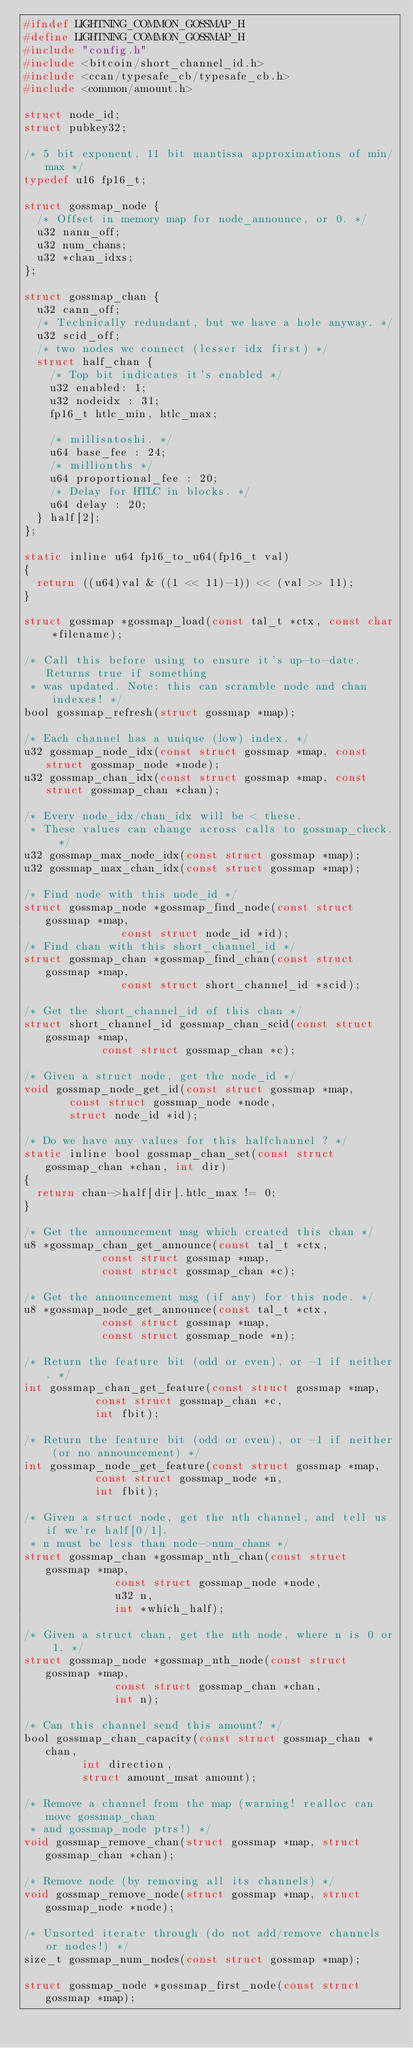<code> <loc_0><loc_0><loc_500><loc_500><_C_>#ifndef LIGHTNING_COMMON_GOSSMAP_H
#define LIGHTNING_COMMON_GOSSMAP_H
#include "config.h"
#include <bitcoin/short_channel_id.h>
#include <ccan/typesafe_cb/typesafe_cb.h>
#include <common/amount.h>

struct node_id;
struct pubkey32;

/* 5 bit exponent, 11 bit mantissa approximations of min/max */
typedef u16 fp16_t;

struct gossmap_node {
	/* Offset in memory map for node_announce, or 0. */
	u32 nann_off;
	u32 num_chans;
	u32 *chan_idxs;
};

struct gossmap_chan {
	u32 cann_off;
	/* Technically redundant, but we have a hole anyway. */
	u32 scid_off;
	/* two nodes we connect (lesser idx first) */
	struct half_chan {
		/* Top bit indicates it's enabled */
		u32 enabled: 1;
		u32 nodeidx : 31;
		fp16_t htlc_min, htlc_max;

		/* millisatoshi. */
		u64 base_fee : 24;
		/* millionths */
		u64 proportional_fee : 20;
		/* Delay for HTLC in blocks. */
		u64 delay : 20;
	} half[2];
};

static inline u64 fp16_to_u64(fp16_t val)
{
	return ((u64)val & ((1 << 11)-1)) << (val >> 11);
}

struct gossmap *gossmap_load(const tal_t *ctx, const char *filename);

/* Call this before using to ensure it's up-to-date.  Returns true if something
 * was updated. Note: this can scramble node and chan indexes! */
bool gossmap_refresh(struct gossmap *map);

/* Each channel has a unique (low) index. */
u32 gossmap_node_idx(const struct gossmap *map, const struct gossmap_node *node);
u32 gossmap_chan_idx(const struct gossmap *map, const struct gossmap_chan *chan);

/* Every node_idx/chan_idx will be < these.
 * These values can change across calls to gossmap_check. */
u32 gossmap_max_node_idx(const struct gossmap *map);
u32 gossmap_max_chan_idx(const struct gossmap *map);

/* Find node with this node_id */
struct gossmap_node *gossmap_find_node(const struct gossmap *map,
				       const struct node_id *id);
/* Find chan with this short_channel_id */
struct gossmap_chan *gossmap_find_chan(const struct gossmap *map,
				       const struct short_channel_id *scid);

/* Get the short_channel_id of this chan */
struct short_channel_id gossmap_chan_scid(const struct gossmap *map,
					  const struct gossmap_chan *c);

/* Given a struct node, get the node_id */
void gossmap_node_get_id(const struct gossmap *map,
			 const struct gossmap_node *node,
			 struct node_id *id);

/* Do we have any values for this halfchannel ? */
static inline bool gossmap_chan_set(const struct gossmap_chan *chan, int dir)
{
	return chan->half[dir].htlc_max != 0;
}

/* Get the announcement msg which created this chan */
u8 *gossmap_chan_get_announce(const tal_t *ctx,
			      const struct gossmap *map,
			      const struct gossmap_chan *c);

/* Get the announcement msg (if any) for this node. */
u8 *gossmap_node_get_announce(const tal_t *ctx,
			      const struct gossmap *map,
			      const struct gossmap_node *n);

/* Return the feature bit (odd or even), or -1 if neither. */
int gossmap_chan_get_feature(const struct gossmap *map,
			     const struct gossmap_chan *c,
			     int fbit);

/* Return the feature bit (odd or even), or -1 if neither (or no announcement) */
int gossmap_node_get_feature(const struct gossmap *map,
			     const struct gossmap_node *n,
			     int fbit);

/* Given a struct node, get the nth channel, and tell us if we're half[0/1].
 * n must be less than node->num_chans */
struct gossmap_chan *gossmap_nth_chan(const struct gossmap *map,
				      const struct gossmap_node *node,
				      u32 n,
				      int *which_half);

/* Given a struct chan, get the nth node, where n is 0 or 1. */
struct gossmap_node *gossmap_nth_node(const struct gossmap *map,
				      const struct gossmap_chan *chan,
				      int n);

/* Can this channel send this amount? */
bool gossmap_chan_capacity(const struct gossmap_chan *chan,
			   int direction,
			   struct amount_msat amount);

/* Remove a channel from the map (warning! realloc can move gossmap_chan
 * and gossmap_node ptrs!) */
void gossmap_remove_chan(struct gossmap *map, struct gossmap_chan *chan);

/* Remove node (by removing all its channels) */
void gossmap_remove_node(struct gossmap *map, struct gossmap_node *node);

/* Unsorted iterate through (do not add/remove channels or nodes!) */
size_t gossmap_num_nodes(const struct gossmap *map);

struct gossmap_node *gossmap_first_node(const struct gossmap *map);</code> 